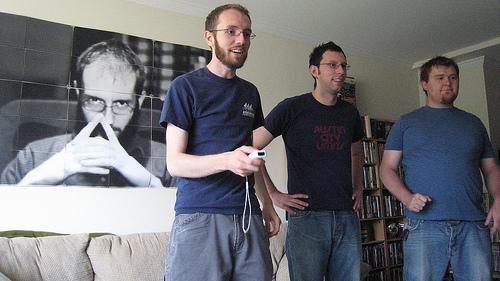How many people are shown?
Give a very brief answer. 3. How many men are smiling with teeth showing?
Give a very brief answer. 2. 